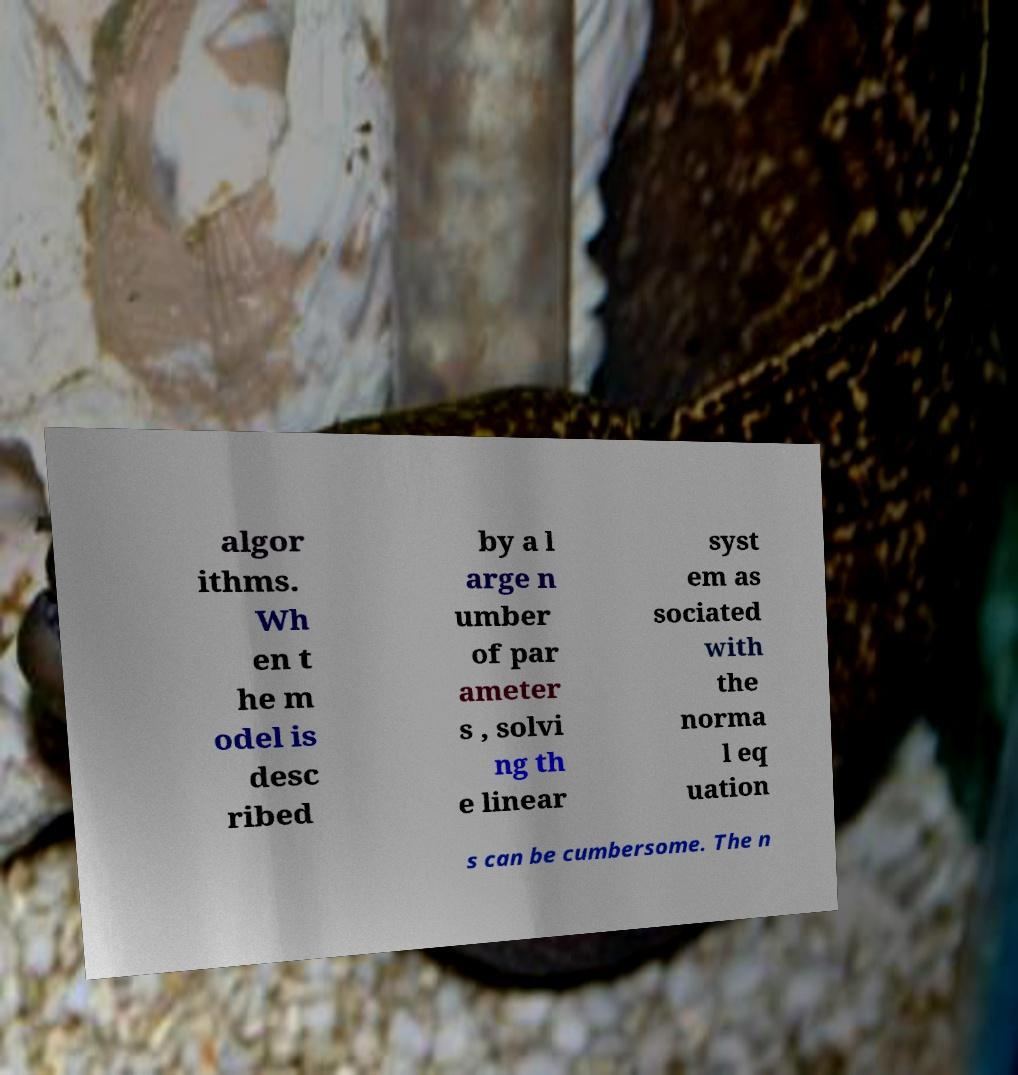Can you accurately transcribe the text from the provided image for me? algor ithms. Wh en t he m odel is desc ribed by a l arge n umber of par ameter s , solvi ng th e linear syst em as sociated with the norma l eq uation s can be cumbersome. The n 